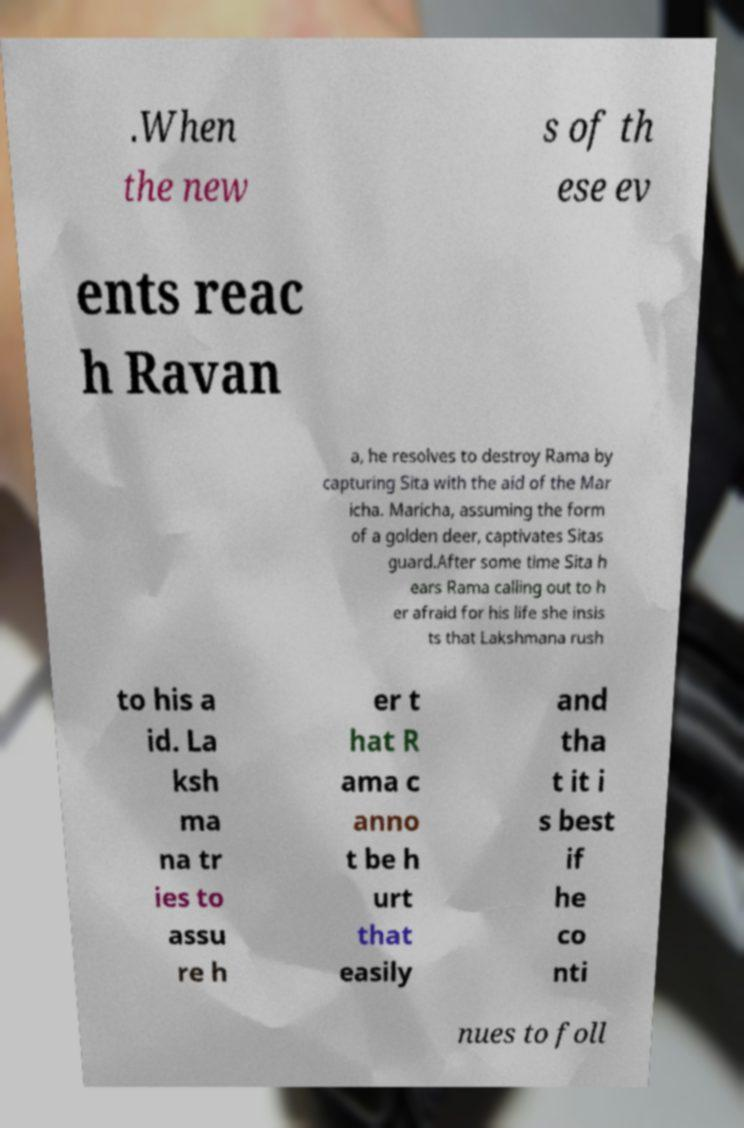Could you assist in decoding the text presented in this image and type it out clearly? .When the new s of th ese ev ents reac h Ravan a, he resolves to destroy Rama by capturing Sita with the aid of the Mar icha. Maricha, assuming the form of a golden deer, captivates Sitas guard.After some time Sita h ears Rama calling out to h er afraid for his life she insis ts that Lakshmana rush to his a id. La ksh ma na tr ies to assu re h er t hat R ama c anno t be h urt that easily and tha t it i s best if he co nti nues to foll 